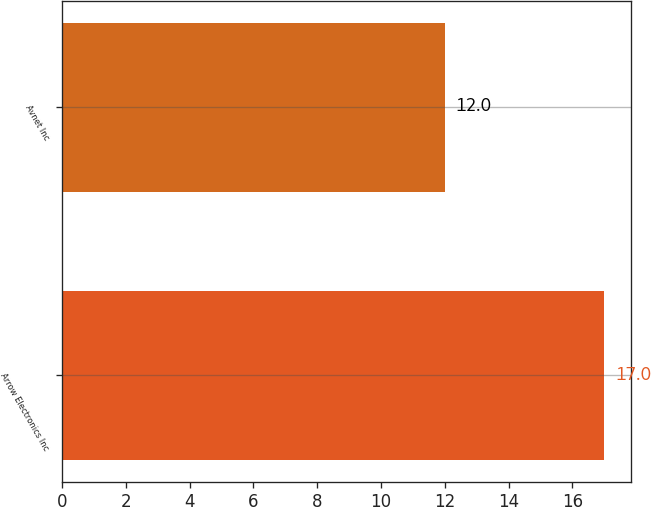Convert chart to OTSL. <chart><loc_0><loc_0><loc_500><loc_500><bar_chart><fcel>Arrow Electronics Inc<fcel>Avnet Inc<nl><fcel>17<fcel>12<nl></chart> 